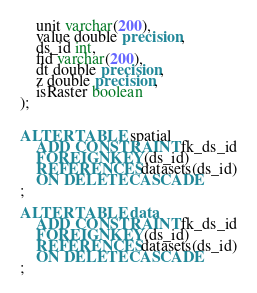<code> <loc_0><loc_0><loc_500><loc_500><_SQL_>    unit varchar(200),
    value double precision,
    ds_id int,
    fid varchar(200),
    dt double precision,
    z double precision,
    isRaster boolean
);


ALTER TABLE spatial
    ADD CONSTRAINT fk_ds_id
    FOREIGN KEY(ds_id) 
    REFERENCES datasets(ds_id)
    ON DELETE CASCADE
;

ALTER TABLE data
    ADD CONSTRAINT fk_ds_id
    FOREIGN KEY(ds_id) 
    REFERENCES datasets(ds_id)
    ON DELETE CASCADE
;</code> 